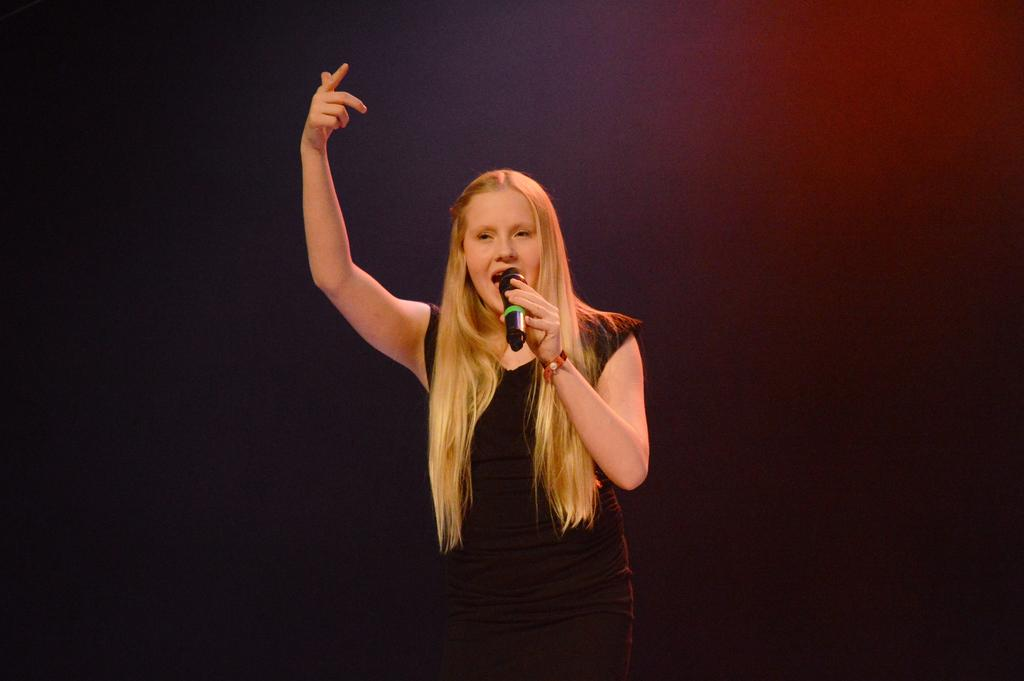Who is the main subject in the image? There is a lady in the image. What is the lady wearing? The lady is wearing a black dress. What is the lady doing in the image? The lady is singing. What object is the lady holding while singing? The lady is holding a microphone. What type of yam is being cooked in the oven in the image? There is no yam or oven present in the image; it features a lady singing while holding a microphone. 